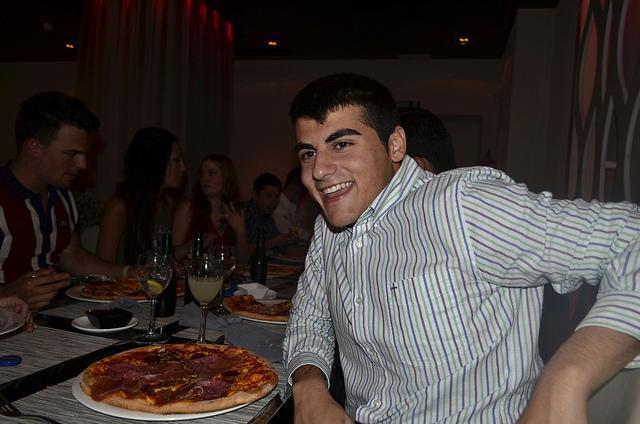How many people do you see?
Give a very brief answer. 7. How many of the utensils are pink?
Give a very brief answer. 0. How many people are there?
Give a very brief answer. 7. 